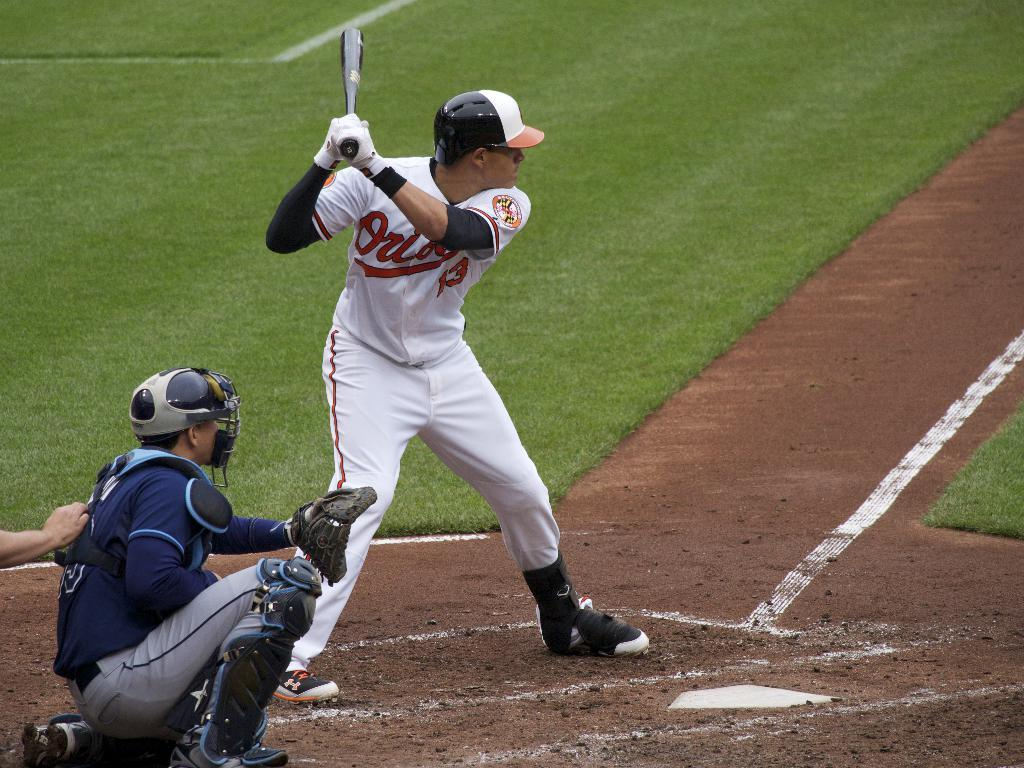<image>
Give a short and clear explanation of the subsequent image. A batter for the Baltimore Orioles stands at the plate. 